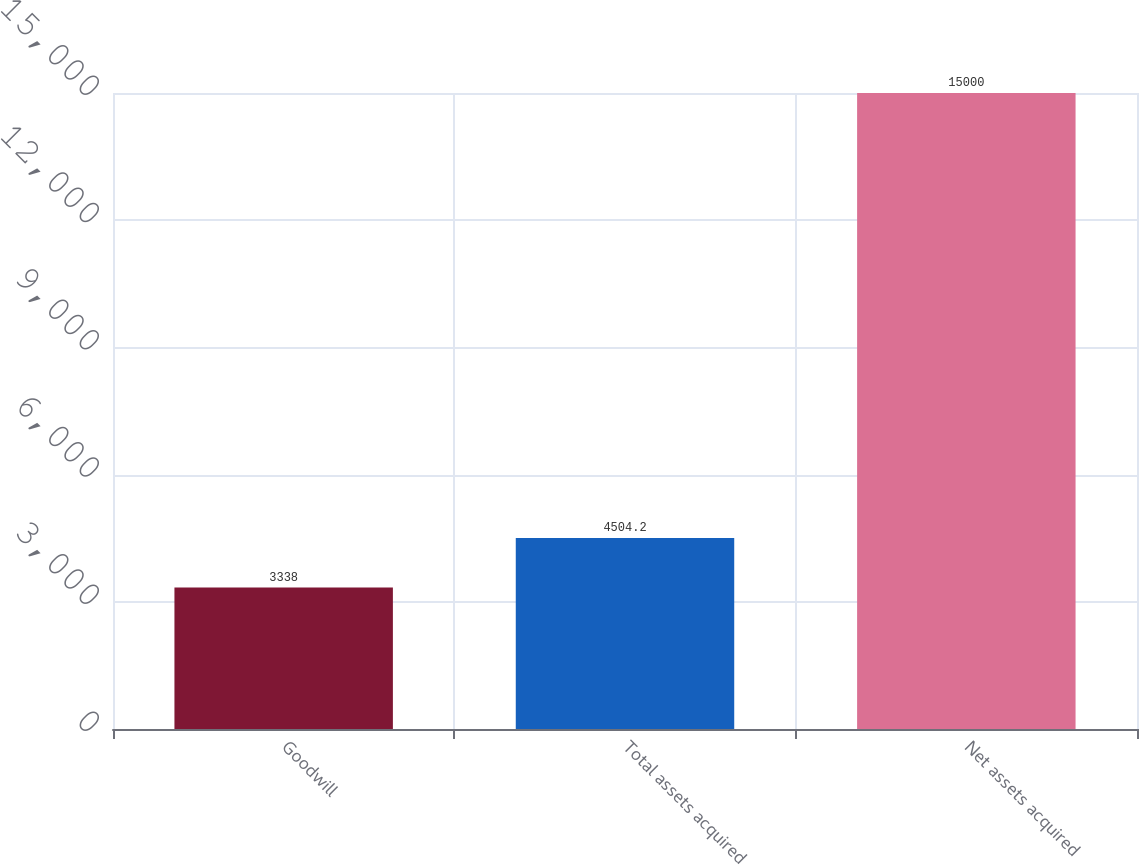<chart> <loc_0><loc_0><loc_500><loc_500><bar_chart><fcel>Goodwill<fcel>Total assets acquired<fcel>Net assets acquired<nl><fcel>3338<fcel>4504.2<fcel>15000<nl></chart> 